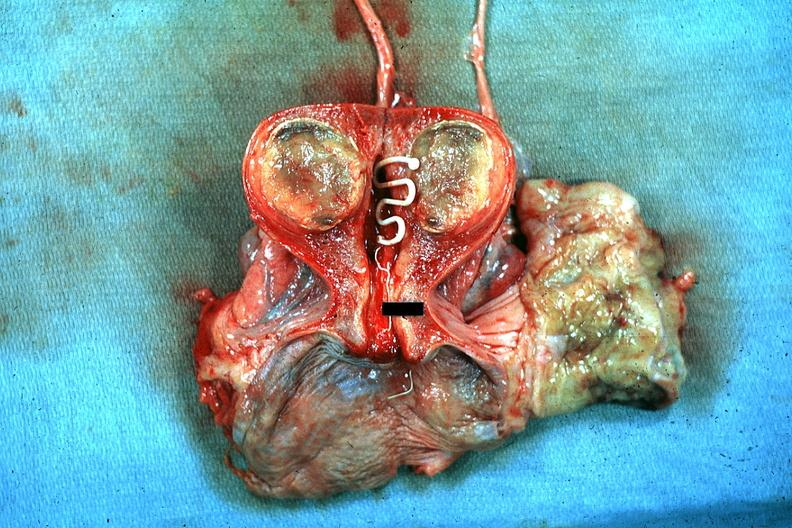s uterus present?
Answer the question using a single word or phrase. Yes 